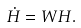Convert formula to latex. <formula><loc_0><loc_0><loc_500><loc_500>\dot { H } = W H .</formula> 